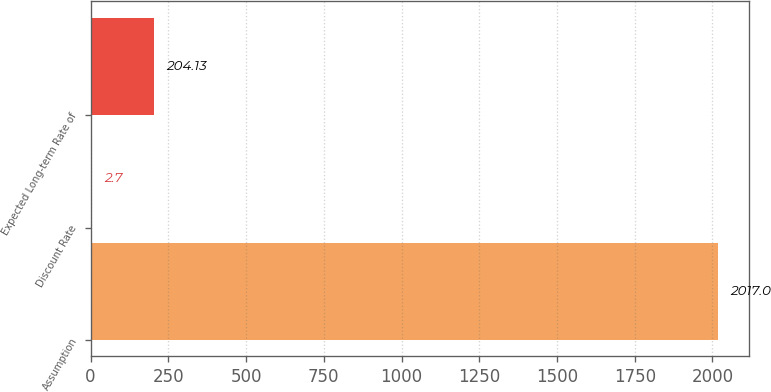Convert chart to OTSL. <chart><loc_0><loc_0><loc_500><loc_500><bar_chart><fcel>Assumption<fcel>Discount Rate<fcel>Expected Long-term Rate of<nl><fcel>2017<fcel>2.7<fcel>204.13<nl></chart> 